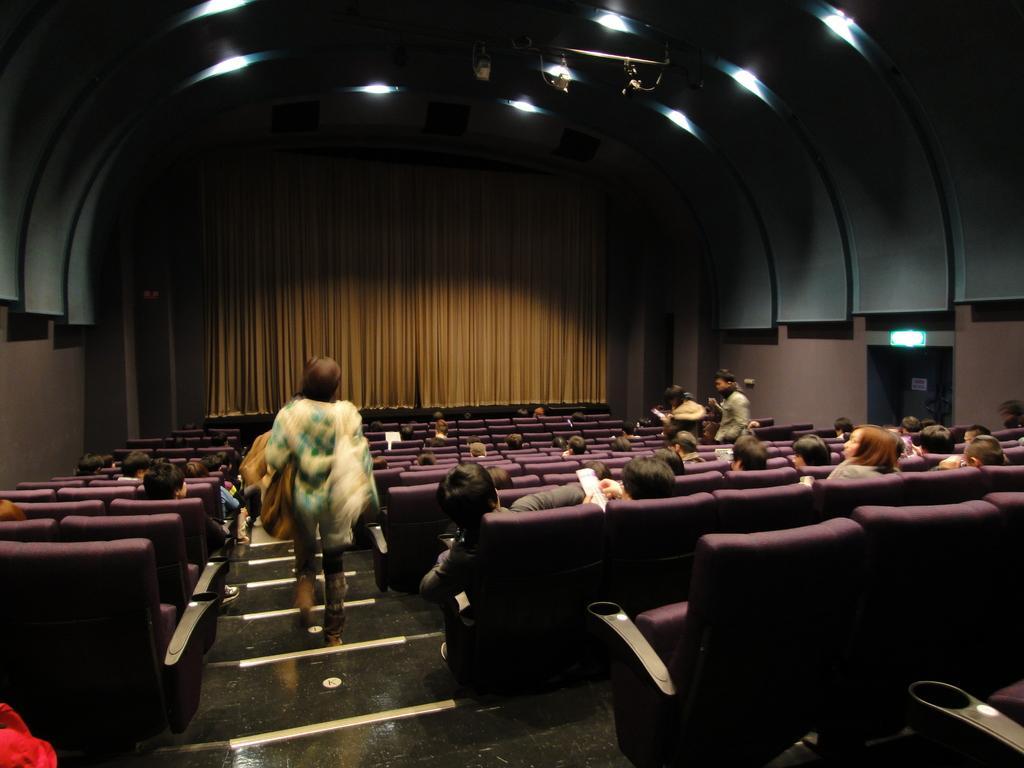How would you summarize this image in a sentence or two? In this image there are people sitting on the chairs. On the left side of the image there is a person walking on the stairs. In the background of the image there are curtains. On top of the image there are lights. 